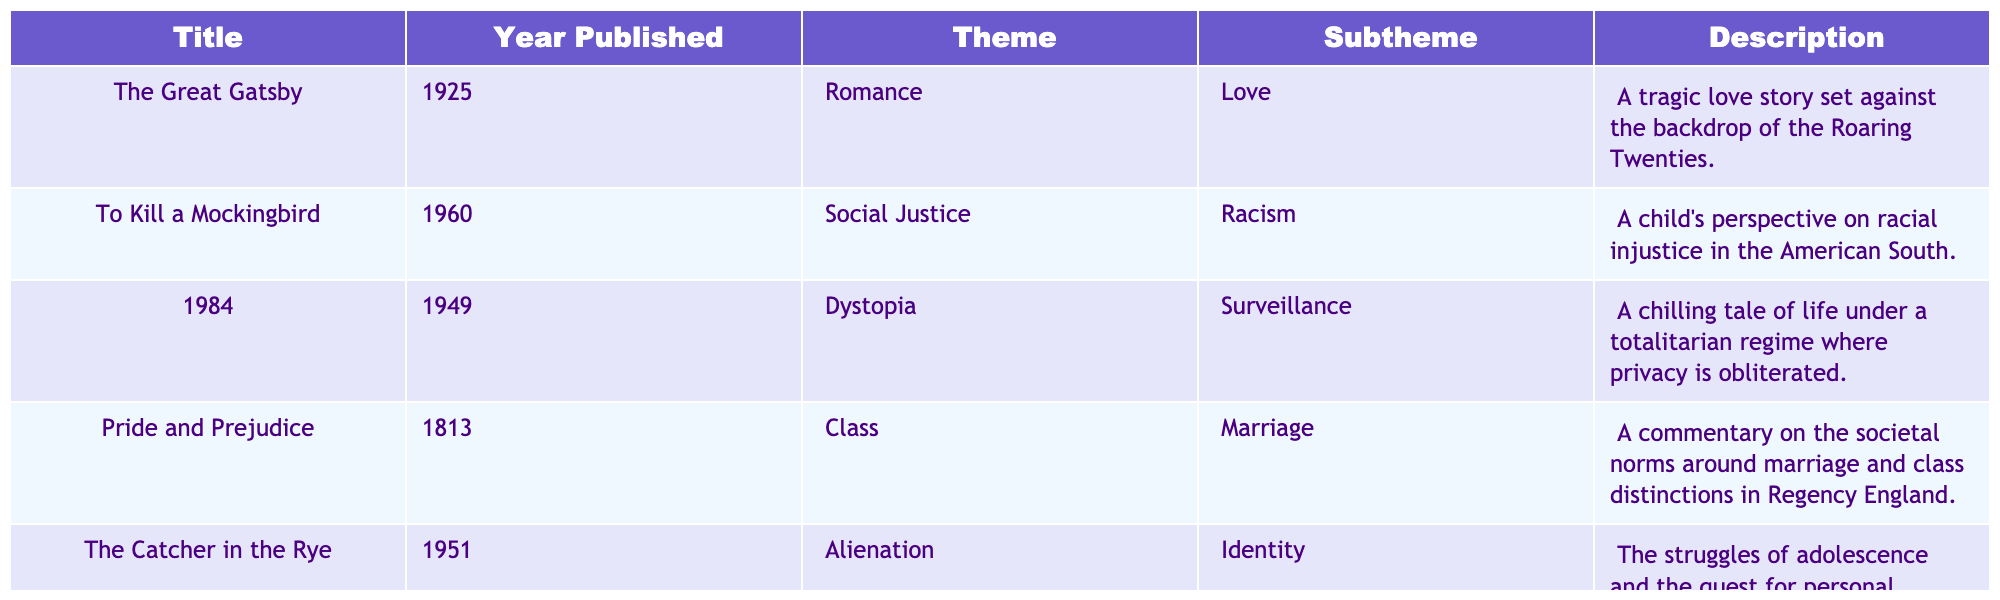What year was "Pride and Prejudice" published? The table shows that "Pride and Prejudice" was published in 1813.
Answer: 1813 Which theme appears most frequently in the table? The themes listed are Romance, Social Justice, Dystopia, Class, and Alienation. Only Romance appears once. Thus, no theme is repeated.
Answer: No themes are repeated Is "1984" focused on the theme of Social Justice? By checking the table, "1984" belongs to the theme of Dystopia and not Social Justice.
Answer: No Which two works explore the theme of Identity? The table lists "The Catcher in the Rye," which has the theme of Alienation and the subtheme of Identity. The table indicates that no other works are categorized under Identity directly.
Answer: Only one work explores Identity What is the subtheme of love in "The Great Gatsby"? The information from the table states that "The Great Gatsby" has the subtheme of Love under the broader theme of Romance.
Answer: Love Which book has a publication year closest to 2000? The publication years listed are 1925, 1960, 1949, 1813, and 1951. The closest is "To Kill a Mockingbird," published in 1960.
Answer: To Kill a Mockingbird (1960) Are there any works that explore both Class and Marriage? The table identifies "Pride and Prejudice" specifically under the theme of Class and the subtheme of Marriage. It is the only work noted as such, indicating it is the only instance.
Answer: Yes, "Pride and Prejudice." What is the average publication year of the books listed? The publication years are 1813, 1925, 1949, 1960, and 1951. The sum of these years is 1930, and there are 5 books, so the average is 1930/5 = 386.
Answer: 1930 Which themes were explored in works published before 1950? The works before 1950 are "Pride and Prejudice" (Class), "The Great Gatsby" (Romance), and "1984" (Dystopia). Thus, the themes include Class, Romance, and Dystopia.
Answer: Class, Romance, Dystopia How do the themes of "The Catcher in the Rye" and "To Kill a Mockingbird" differ? The table shows "The Catcher in the Rye" focuses on Alienation and Identity, while "To Kill a Mockingbird" is centered on Social Justice and Racism, indicating a thematic difference between individual struggle and societal issues.
Answer: They differ significantly 